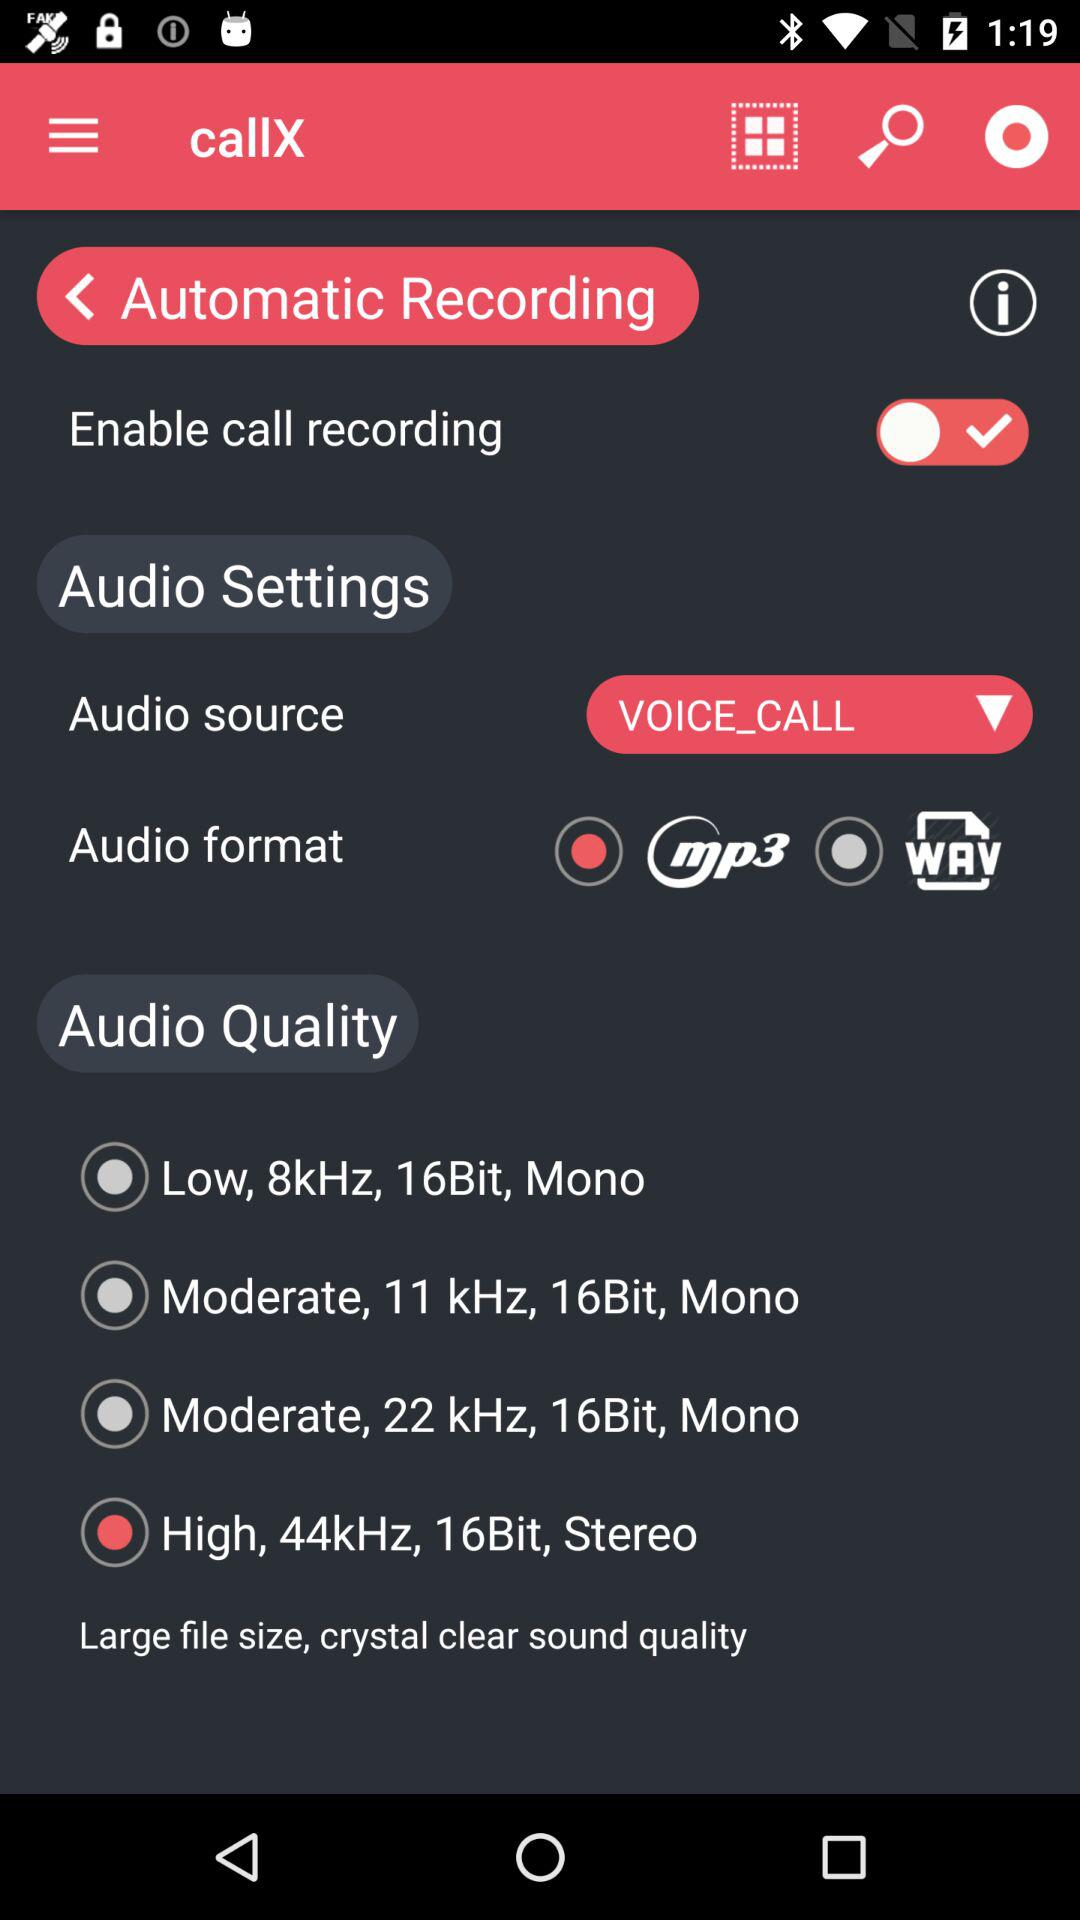What is the audio quality? The audio quality is high, 44kHz, 16Bit and stereo. 